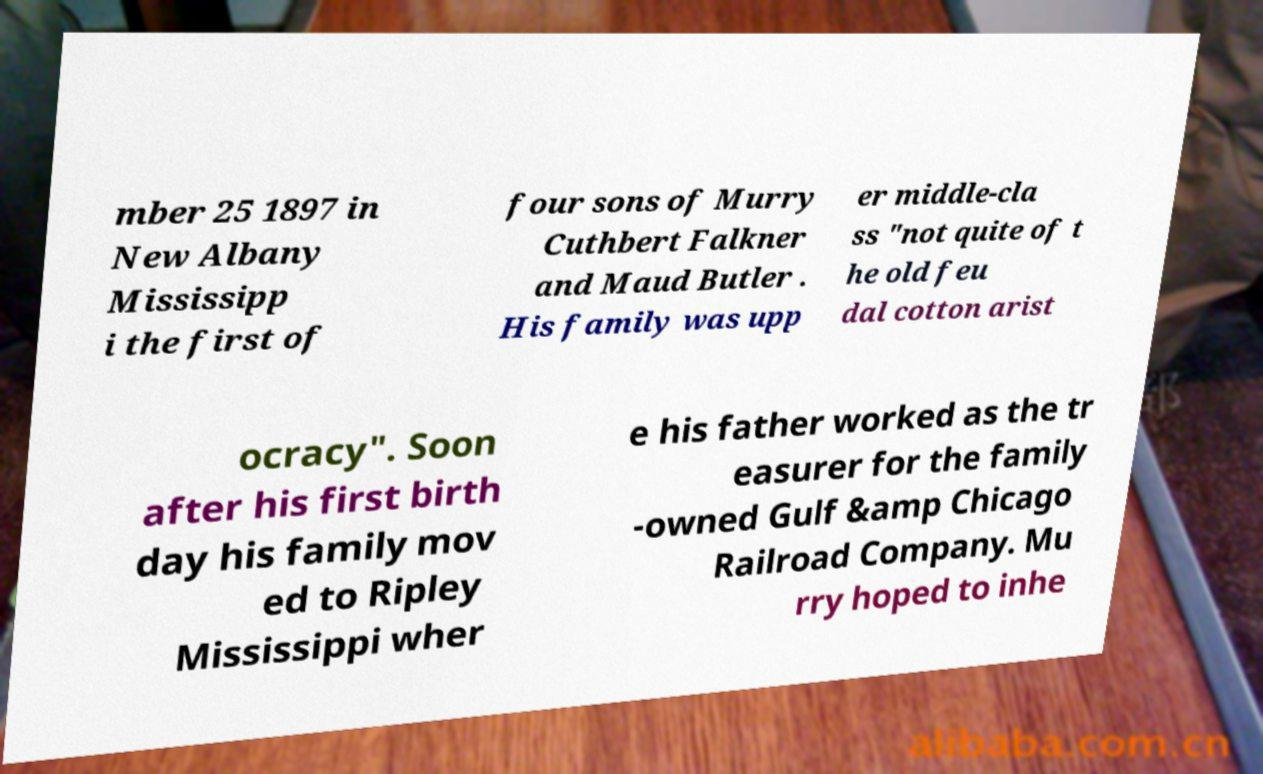Please read and relay the text visible in this image. What does it say? mber 25 1897 in New Albany Mississipp i the first of four sons of Murry Cuthbert Falkner and Maud Butler . His family was upp er middle-cla ss "not quite of t he old feu dal cotton arist ocracy". Soon after his first birth day his family mov ed to Ripley Mississippi wher e his father worked as the tr easurer for the family -owned Gulf &amp Chicago Railroad Company. Mu rry hoped to inhe 